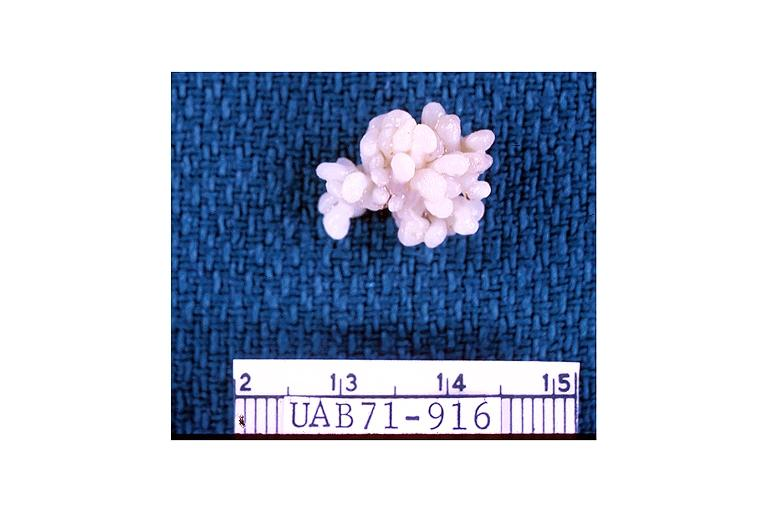what is present?
Answer the question using a single word or phrase. Oral 